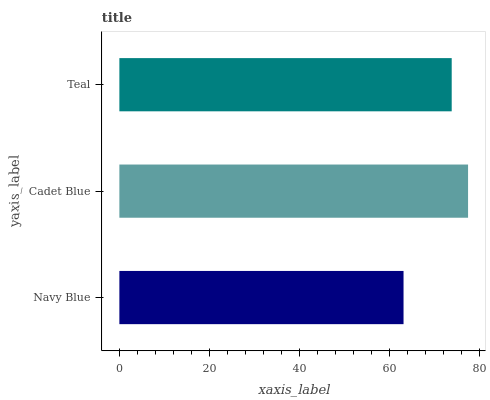Is Navy Blue the minimum?
Answer yes or no. Yes. Is Cadet Blue the maximum?
Answer yes or no. Yes. Is Teal the minimum?
Answer yes or no. No. Is Teal the maximum?
Answer yes or no. No. Is Cadet Blue greater than Teal?
Answer yes or no. Yes. Is Teal less than Cadet Blue?
Answer yes or no. Yes. Is Teal greater than Cadet Blue?
Answer yes or no. No. Is Cadet Blue less than Teal?
Answer yes or no. No. Is Teal the high median?
Answer yes or no. Yes. Is Teal the low median?
Answer yes or no. Yes. Is Navy Blue the high median?
Answer yes or no. No. Is Navy Blue the low median?
Answer yes or no. No. 